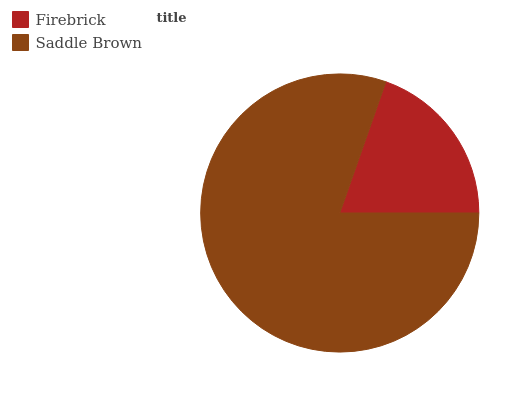Is Firebrick the minimum?
Answer yes or no. Yes. Is Saddle Brown the maximum?
Answer yes or no. Yes. Is Saddle Brown the minimum?
Answer yes or no. No. Is Saddle Brown greater than Firebrick?
Answer yes or no. Yes. Is Firebrick less than Saddle Brown?
Answer yes or no. Yes. Is Firebrick greater than Saddle Brown?
Answer yes or no. No. Is Saddle Brown less than Firebrick?
Answer yes or no. No. Is Saddle Brown the high median?
Answer yes or no. Yes. Is Firebrick the low median?
Answer yes or no. Yes. Is Firebrick the high median?
Answer yes or no. No. Is Saddle Brown the low median?
Answer yes or no. No. 